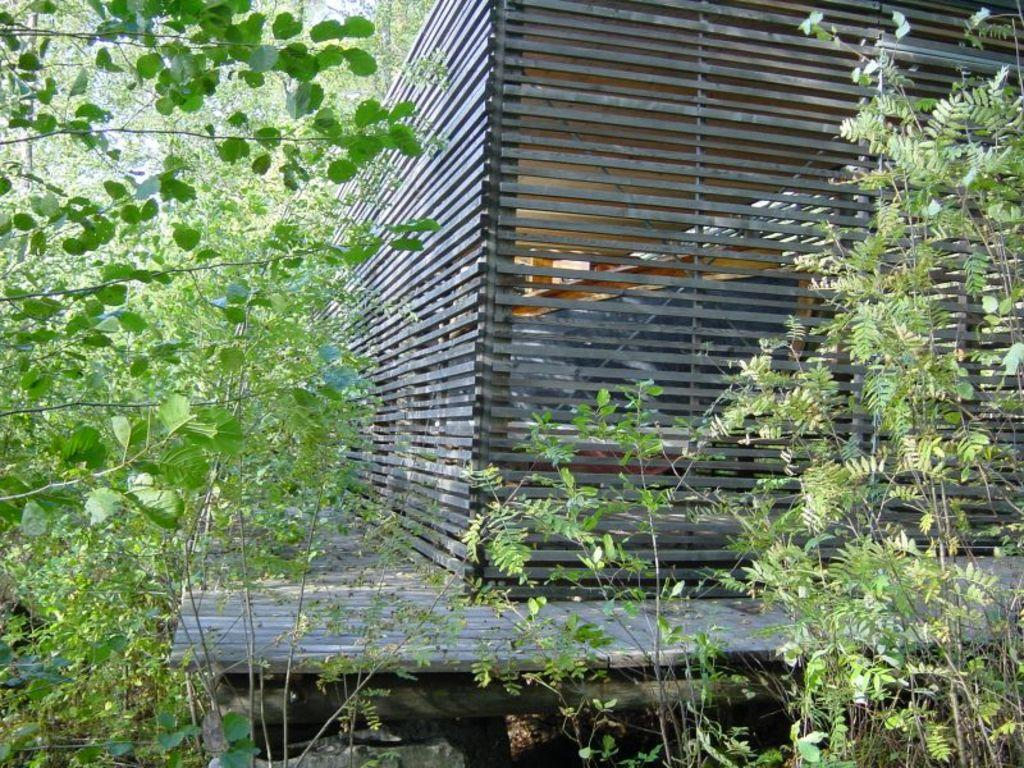What type of house is in the image? There is a wooden house in the image. What can be seen in the background of the image? There are trees in the image. What other types of vegetation are present in the image? There are plants in the image. How many sisters are playing with the beetle in the image? There is no beetle or sisters present in the image. 